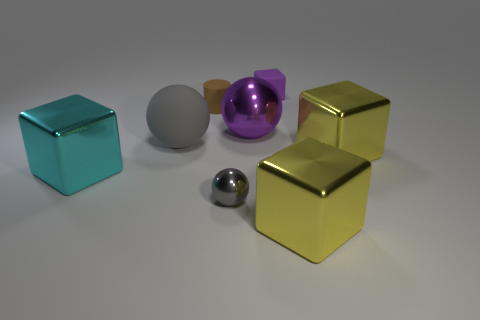Is there a large block on the right side of the big metal block in front of the metal ball that is in front of the big purple metal thing?
Offer a terse response. Yes. The small shiny object that is the same color as the big rubber thing is what shape?
Make the answer very short. Sphere. How many small things are either brown rubber cylinders or yellow cubes?
Provide a succinct answer. 1. There is a small thing that is in front of the cyan cube; is it the same shape as the purple matte object?
Provide a short and direct response. No. Are there fewer big matte balls than small green things?
Make the answer very short. No. Is there any other thing that is the same color as the cylinder?
Provide a succinct answer. No. The yellow thing behind the small ball has what shape?
Offer a very short reply. Cube. Does the small sphere have the same color as the rubber thing in front of the big purple ball?
Offer a terse response. Yes. Are there an equal number of big cyan things that are in front of the brown cylinder and small gray metallic things right of the small cube?
Offer a very short reply. No. How many other objects are there of the same size as the cyan cube?
Your answer should be very brief. 4. 